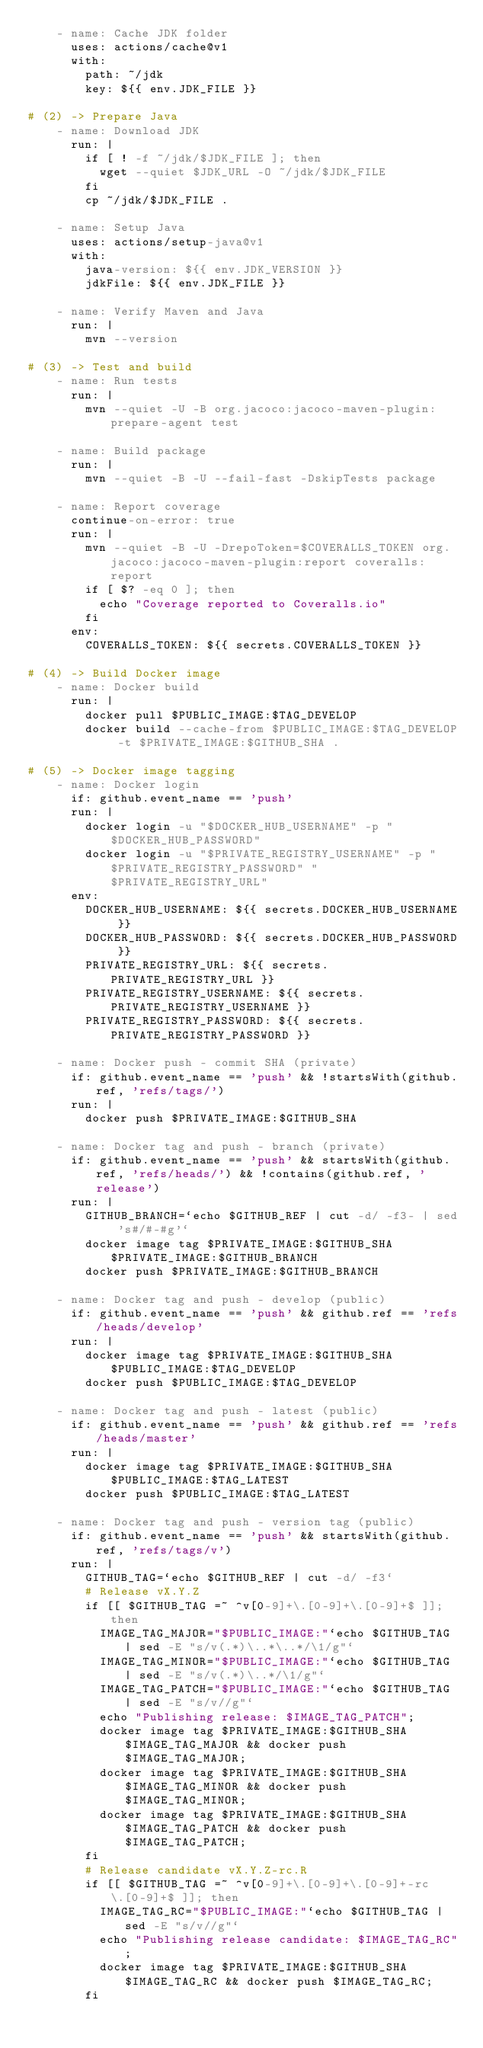Convert code to text. <code><loc_0><loc_0><loc_500><loc_500><_YAML_>    - name: Cache JDK folder
      uses: actions/cache@v1
      with:
        path: ~/jdk
        key: ${{ env.JDK_FILE }}

# (2) -> Prepare Java
    - name: Download JDK
      run: |
        if [ ! -f ~/jdk/$JDK_FILE ]; then
          wget --quiet $JDK_URL -O ~/jdk/$JDK_FILE
        fi
        cp ~/jdk/$JDK_FILE .

    - name: Setup Java
      uses: actions/setup-java@v1
      with:
        java-version: ${{ env.JDK_VERSION }}
        jdkFile: ${{ env.JDK_FILE }}

    - name: Verify Maven and Java
      run: |
        mvn --version

# (3) -> Test and build
    - name: Run tests
      run: |
        mvn --quiet -U -B org.jacoco:jacoco-maven-plugin:prepare-agent test

    - name: Build package
      run: |
        mvn --quiet -B -U --fail-fast -DskipTests package

    - name: Report coverage
      continue-on-error: true
      run: |
        mvn --quiet -B -U -DrepoToken=$COVERALLS_TOKEN org.jacoco:jacoco-maven-plugin:report coveralls:report
        if [ $? -eq 0 ]; then
          echo "Coverage reported to Coveralls.io"
        fi
      env:
        COVERALLS_TOKEN: ${{ secrets.COVERALLS_TOKEN }}

# (4) -> Build Docker image
    - name: Docker build
      run: |
        docker pull $PUBLIC_IMAGE:$TAG_DEVELOP
        docker build --cache-from $PUBLIC_IMAGE:$TAG_DEVELOP -t $PRIVATE_IMAGE:$GITHUB_SHA .

# (5) -> Docker image tagging
    - name: Docker login
      if: github.event_name == 'push'
      run: |
        docker login -u "$DOCKER_HUB_USERNAME" -p "$DOCKER_HUB_PASSWORD"
        docker login -u "$PRIVATE_REGISTRY_USERNAME" -p "$PRIVATE_REGISTRY_PASSWORD" "$PRIVATE_REGISTRY_URL"
      env:
        DOCKER_HUB_USERNAME: ${{ secrets.DOCKER_HUB_USERNAME }}
        DOCKER_HUB_PASSWORD: ${{ secrets.DOCKER_HUB_PASSWORD }}
        PRIVATE_REGISTRY_URL: ${{ secrets.PRIVATE_REGISTRY_URL }}
        PRIVATE_REGISTRY_USERNAME: ${{ secrets.PRIVATE_REGISTRY_USERNAME }}
        PRIVATE_REGISTRY_PASSWORD: ${{ secrets.PRIVATE_REGISTRY_PASSWORD }}

    - name: Docker push - commit SHA (private)
      if: github.event_name == 'push' && !startsWith(github.ref, 'refs/tags/')
      run: |
        docker push $PRIVATE_IMAGE:$GITHUB_SHA

    - name: Docker tag and push - branch (private)
      if: github.event_name == 'push' && startsWith(github.ref, 'refs/heads/') && !contains(github.ref, 'release')
      run: |
        GITHUB_BRANCH=`echo $GITHUB_REF | cut -d/ -f3- | sed 's#/#-#g'`
        docker image tag $PRIVATE_IMAGE:$GITHUB_SHA $PRIVATE_IMAGE:$GITHUB_BRANCH
        docker push $PRIVATE_IMAGE:$GITHUB_BRANCH

    - name: Docker tag and push - develop (public)
      if: github.event_name == 'push' && github.ref == 'refs/heads/develop'
      run: |
        docker image tag $PRIVATE_IMAGE:$GITHUB_SHA $PUBLIC_IMAGE:$TAG_DEVELOP
        docker push $PUBLIC_IMAGE:$TAG_DEVELOP

    - name: Docker tag and push - latest (public)
      if: github.event_name == 'push' && github.ref == 'refs/heads/master'
      run: |
        docker image tag $PRIVATE_IMAGE:$GITHUB_SHA $PUBLIC_IMAGE:$TAG_LATEST
        docker push $PUBLIC_IMAGE:$TAG_LATEST

    - name: Docker tag and push - version tag (public)
      if: github.event_name == 'push' && startsWith(github.ref, 'refs/tags/v')
      run: |
        GITHUB_TAG=`echo $GITHUB_REF | cut -d/ -f3` 
        # Release vX.Y.Z
        if [[ $GITHUB_TAG =~ ^v[0-9]+\.[0-9]+\.[0-9]+$ ]]; then
          IMAGE_TAG_MAJOR="$PUBLIC_IMAGE:"`echo $GITHUB_TAG | sed -E "s/v(.*)\..*\..*/\1/g"`
          IMAGE_TAG_MINOR="$PUBLIC_IMAGE:"`echo $GITHUB_TAG | sed -E "s/v(.*)\..*/\1/g"`
          IMAGE_TAG_PATCH="$PUBLIC_IMAGE:"`echo $GITHUB_TAG | sed -E "s/v//g"`
          echo "Publishing release: $IMAGE_TAG_PATCH";
          docker image tag $PRIVATE_IMAGE:$GITHUB_SHA $IMAGE_TAG_MAJOR && docker push $IMAGE_TAG_MAJOR;
          docker image tag $PRIVATE_IMAGE:$GITHUB_SHA $IMAGE_TAG_MINOR && docker push $IMAGE_TAG_MINOR;
          docker image tag $PRIVATE_IMAGE:$GITHUB_SHA $IMAGE_TAG_PATCH && docker push $IMAGE_TAG_PATCH;
        fi
        # Release candidate vX.Y.Z-rc.R
        if [[ $GITHUB_TAG =~ ^v[0-9]+\.[0-9]+\.[0-9]+-rc\.[0-9]+$ ]]; then
          IMAGE_TAG_RC="$PUBLIC_IMAGE:"`echo $GITHUB_TAG | sed -E "s/v//g"`
          echo "Publishing release candidate: $IMAGE_TAG_RC";
          docker image tag $PRIVATE_IMAGE:$GITHUB_SHA $IMAGE_TAG_RC && docker push $IMAGE_TAG_RC;
        fi
</code> 